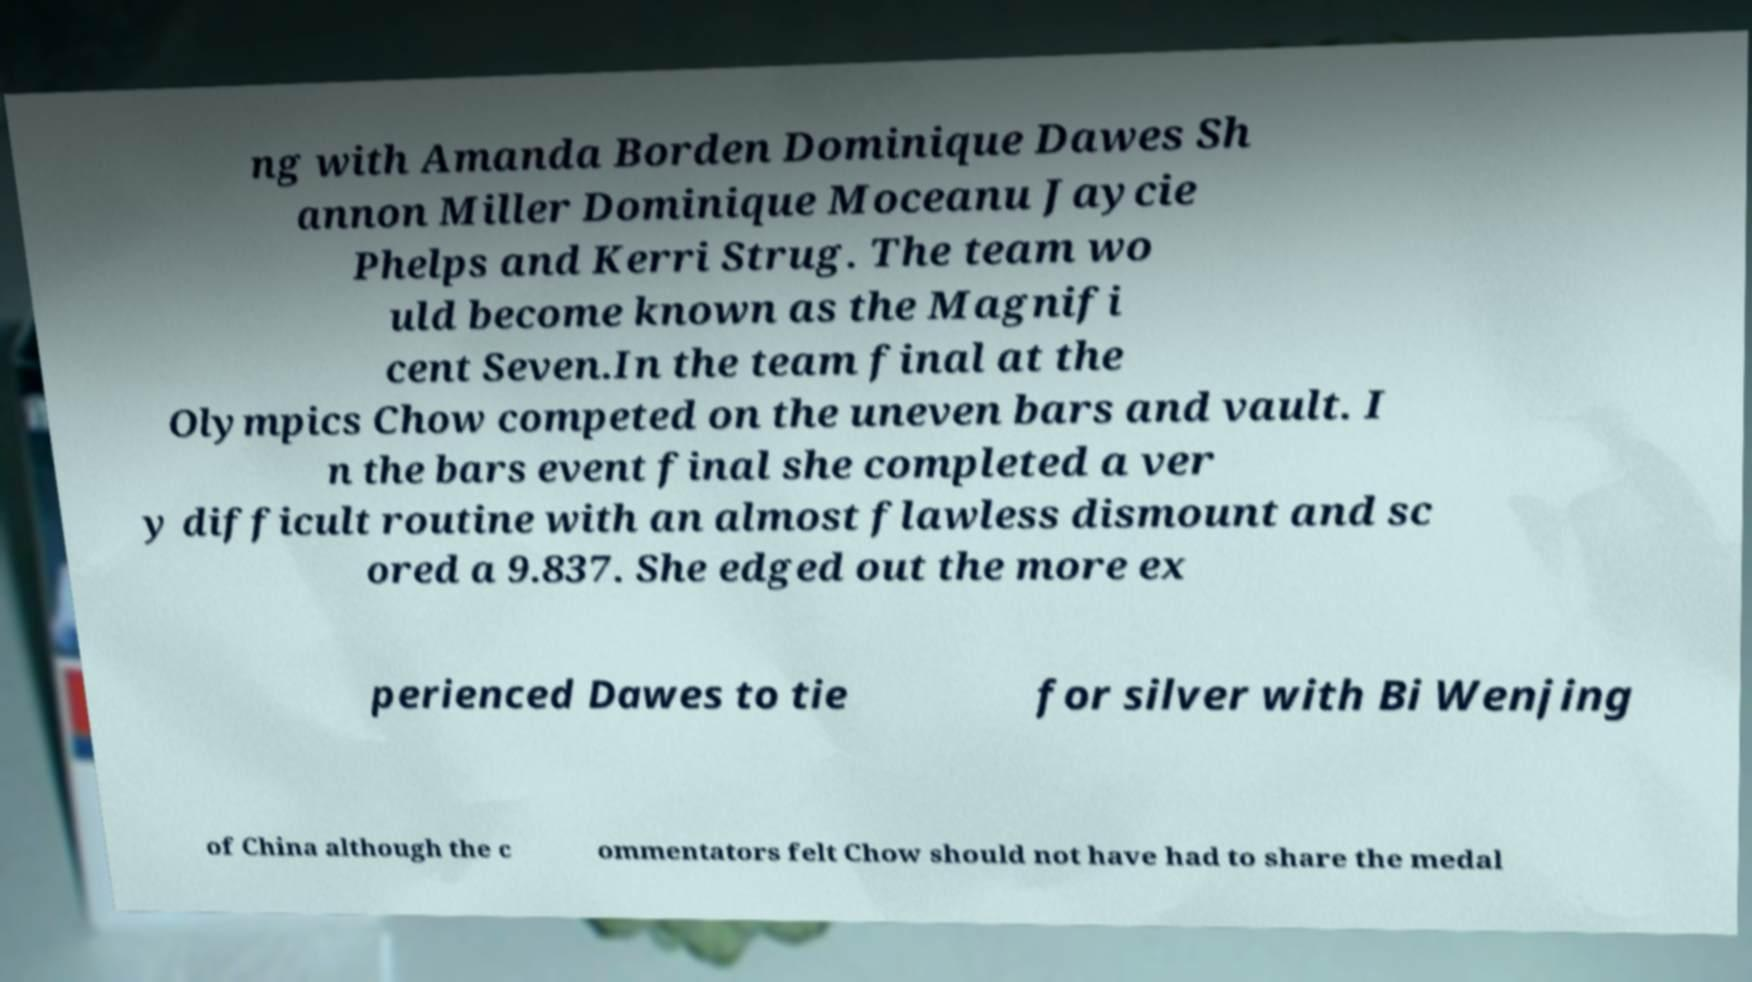For documentation purposes, I need the text within this image transcribed. Could you provide that? ng with Amanda Borden Dominique Dawes Sh annon Miller Dominique Moceanu Jaycie Phelps and Kerri Strug. The team wo uld become known as the Magnifi cent Seven.In the team final at the Olympics Chow competed on the uneven bars and vault. I n the bars event final she completed a ver y difficult routine with an almost flawless dismount and sc ored a 9.837. She edged out the more ex perienced Dawes to tie for silver with Bi Wenjing of China although the c ommentators felt Chow should not have had to share the medal 